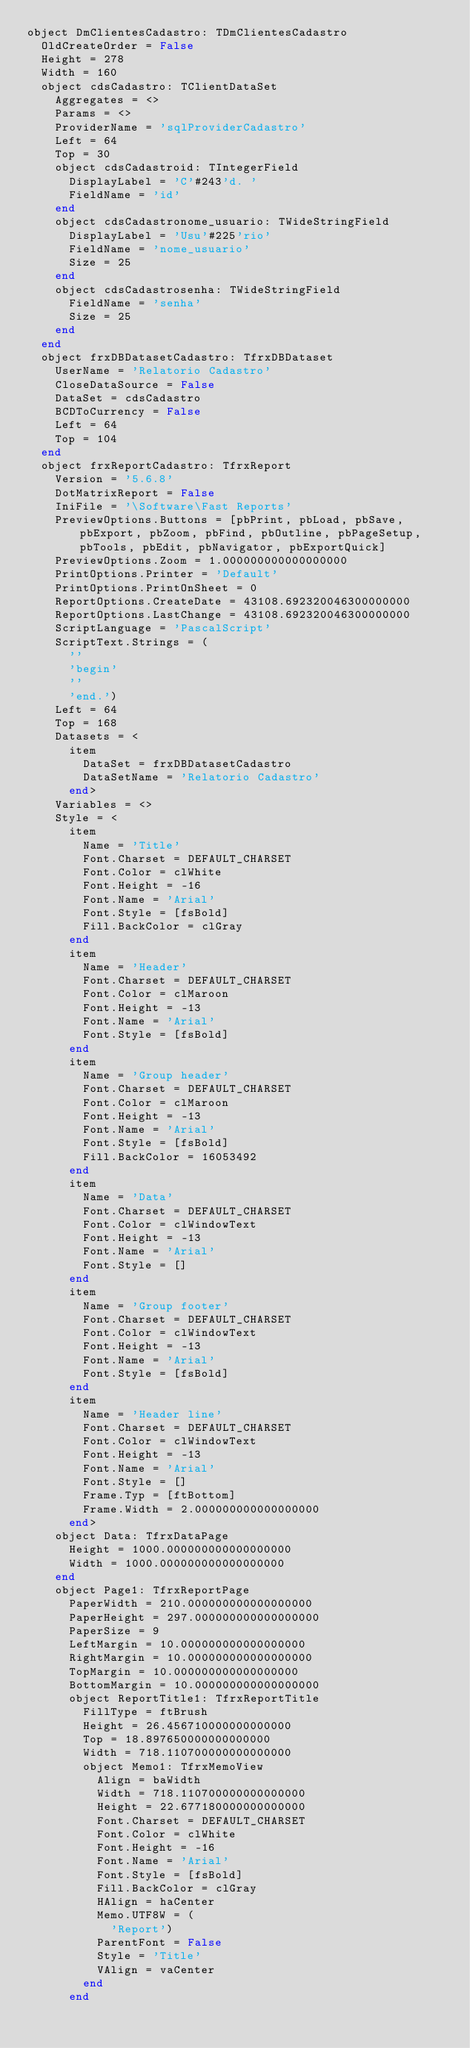Convert code to text. <code><loc_0><loc_0><loc_500><loc_500><_Pascal_>object DmClientesCadastro: TDmClientesCadastro
  OldCreateOrder = False
  Height = 278
  Width = 160
  object cdsCadastro: TClientDataSet
    Aggregates = <>
    Params = <>
    ProviderName = 'sqlProviderCadastro'
    Left = 64
    Top = 30
    object cdsCadastroid: TIntegerField
      DisplayLabel = 'C'#243'd. '
      FieldName = 'id'
    end
    object cdsCadastronome_usuario: TWideStringField
      DisplayLabel = 'Usu'#225'rio'
      FieldName = 'nome_usuario'
      Size = 25
    end
    object cdsCadastrosenha: TWideStringField
      FieldName = 'senha'
      Size = 25
    end
  end
  object frxDBDatasetCadastro: TfrxDBDataset
    UserName = 'Relatorio Cadastro'
    CloseDataSource = False
    DataSet = cdsCadastro
    BCDToCurrency = False
    Left = 64
    Top = 104
  end
  object frxReportCadastro: TfrxReport
    Version = '5.6.8'
    DotMatrixReport = False
    IniFile = '\Software\Fast Reports'
    PreviewOptions.Buttons = [pbPrint, pbLoad, pbSave, pbExport, pbZoom, pbFind, pbOutline, pbPageSetup, pbTools, pbEdit, pbNavigator, pbExportQuick]
    PreviewOptions.Zoom = 1.000000000000000000
    PrintOptions.Printer = 'Default'
    PrintOptions.PrintOnSheet = 0
    ReportOptions.CreateDate = 43108.692320046300000000
    ReportOptions.LastChange = 43108.692320046300000000
    ScriptLanguage = 'PascalScript'
    ScriptText.Strings = (
      ''
      'begin'
      ''
      'end.')
    Left = 64
    Top = 168
    Datasets = <
      item
        DataSet = frxDBDatasetCadastro
        DataSetName = 'Relatorio Cadastro'
      end>
    Variables = <>
    Style = <
      item
        Name = 'Title'
        Font.Charset = DEFAULT_CHARSET
        Font.Color = clWhite
        Font.Height = -16
        Font.Name = 'Arial'
        Font.Style = [fsBold]
        Fill.BackColor = clGray
      end
      item
        Name = 'Header'
        Font.Charset = DEFAULT_CHARSET
        Font.Color = clMaroon
        Font.Height = -13
        Font.Name = 'Arial'
        Font.Style = [fsBold]
      end
      item
        Name = 'Group header'
        Font.Charset = DEFAULT_CHARSET
        Font.Color = clMaroon
        Font.Height = -13
        Font.Name = 'Arial'
        Font.Style = [fsBold]
        Fill.BackColor = 16053492
      end
      item
        Name = 'Data'
        Font.Charset = DEFAULT_CHARSET
        Font.Color = clWindowText
        Font.Height = -13
        Font.Name = 'Arial'
        Font.Style = []
      end
      item
        Name = 'Group footer'
        Font.Charset = DEFAULT_CHARSET
        Font.Color = clWindowText
        Font.Height = -13
        Font.Name = 'Arial'
        Font.Style = [fsBold]
      end
      item
        Name = 'Header line'
        Font.Charset = DEFAULT_CHARSET
        Font.Color = clWindowText
        Font.Height = -13
        Font.Name = 'Arial'
        Font.Style = []
        Frame.Typ = [ftBottom]
        Frame.Width = 2.000000000000000000
      end>
    object Data: TfrxDataPage
      Height = 1000.000000000000000000
      Width = 1000.000000000000000000
    end
    object Page1: TfrxReportPage
      PaperWidth = 210.000000000000000000
      PaperHeight = 297.000000000000000000
      PaperSize = 9
      LeftMargin = 10.000000000000000000
      RightMargin = 10.000000000000000000
      TopMargin = 10.000000000000000000
      BottomMargin = 10.000000000000000000
      object ReportTitle1: TfrxReportTitle
        FillType = ftBrush
        Height = 26.456710000000000000
        Top = 18.897650000000000000
        Width = 718.110700000000000000
        object Memo1: TfrxMemoView
          Align = baWidth
          Width = 718.110700000000000000
          Height = 22.677180000000000000
          Font.Charset = DEFAULT_CHARSET
          Font.Color = clWhite
          Font.Height = -16
          Font.Name = 'Arial'
          Font.Style = [fsBold]
          Fill.BackColor = clGray
          HAlign = haCenter
          Memo.UTF8W = (
            'Report')
          ParentFont = False
          Style = 'Title'
          VAlign = vaCenter
        end
      end</code> 